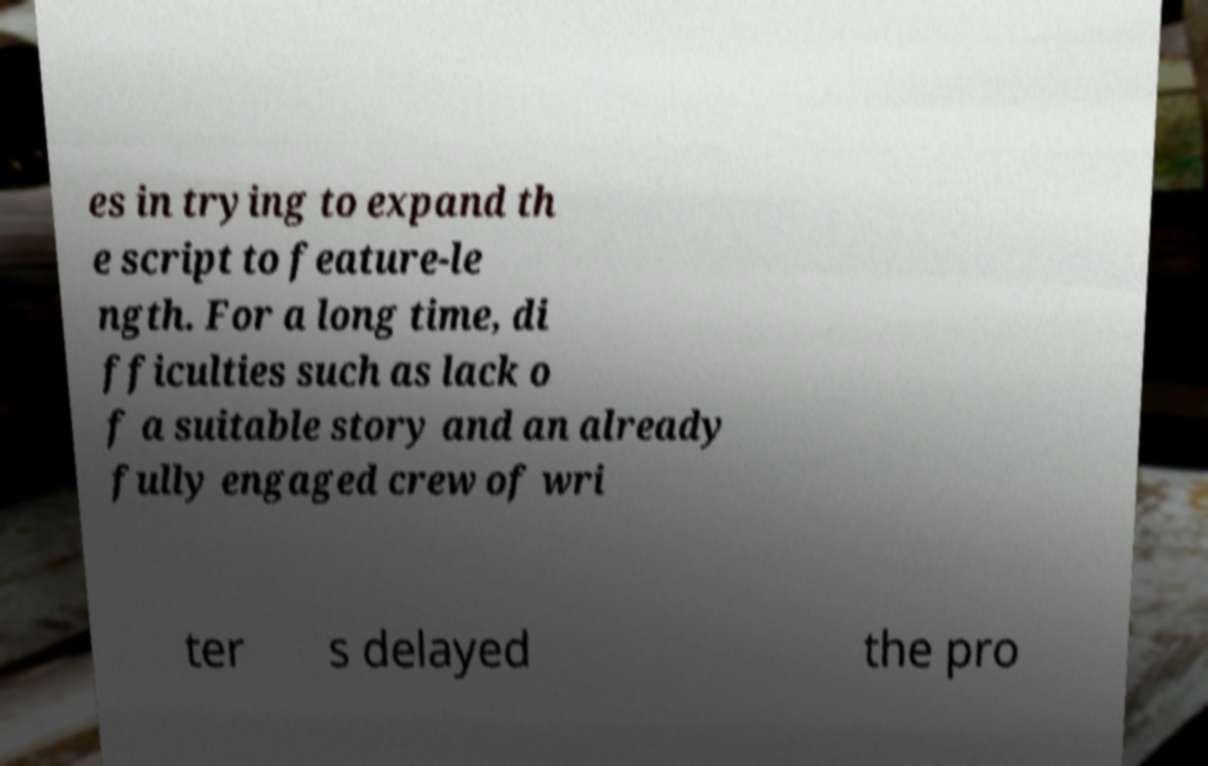Could you assist in decoding the text presented in this image and type it out clearly? es in trying to expand th e script to feature-le ngth. For a long time, di fficulties such as lack o f a suitable story and an already fully engaged crew of wri ter s delayed the pro 